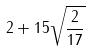Convert formula to latex. <formula><loc_0><loc_0><loc_500><loc_500>2 + 1 5 \sqrt { \frac { 2 } { 1 7 } }</formula> 